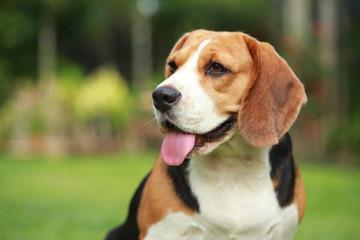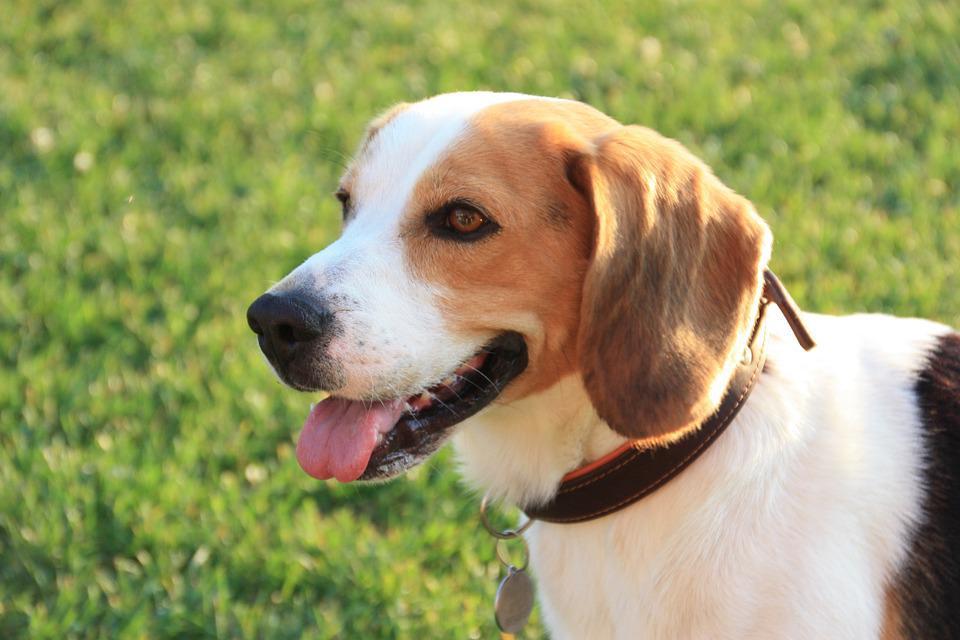The first image is the image on the left, the second image is the image on the right. Given the left and right images, does the statement "At least one dog has its mouth open." hold true? Answer yes or no. Yes. 